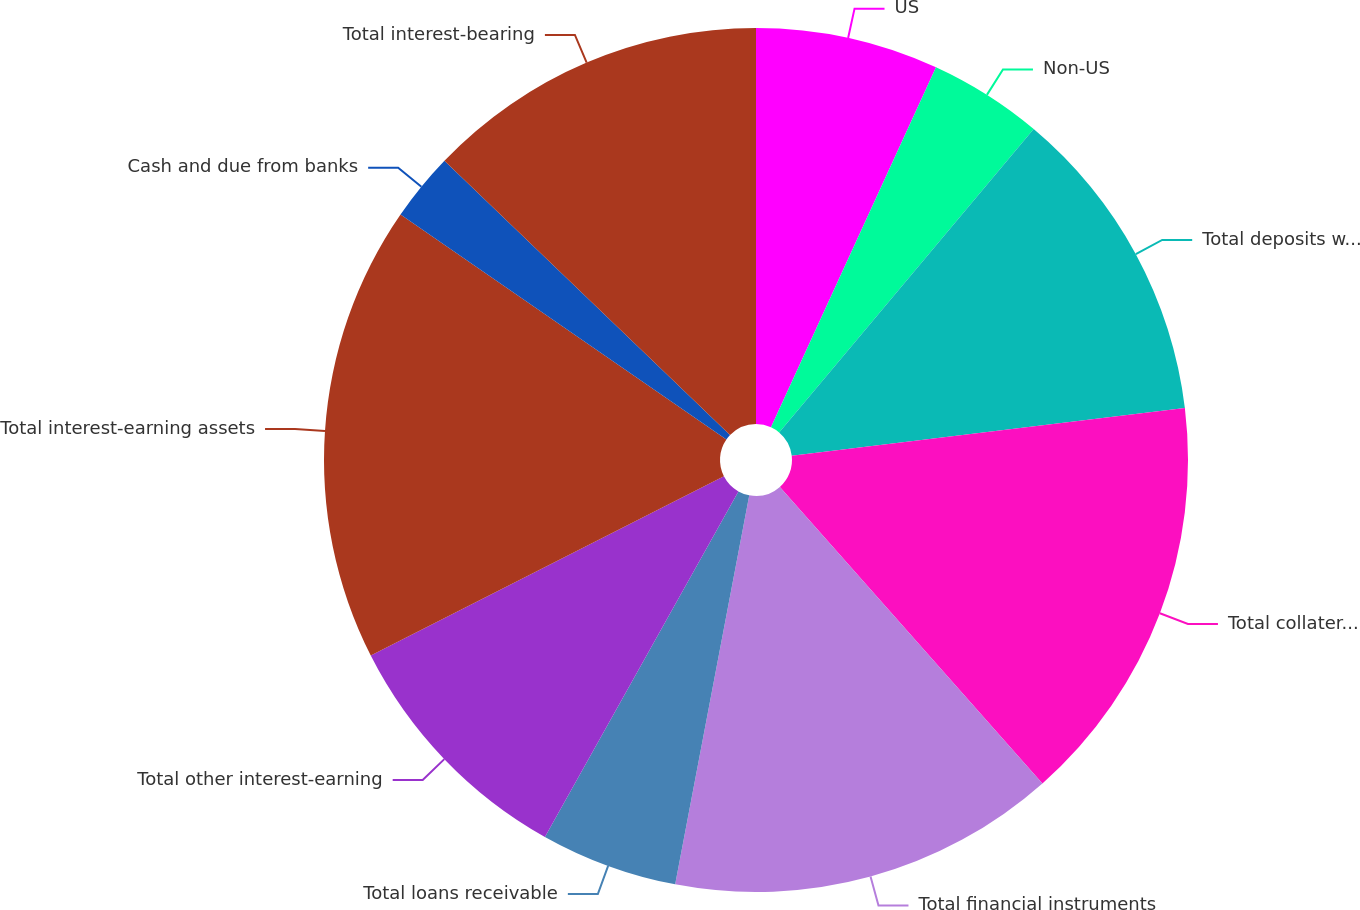Convert chart. <chart><loc_0><loc_0><loc_500><loc_500><pie_chart><fcel>US<fcel>Non-US<fcel>Total deposits with banks<fcel>Total collateralized<fcel>Total financial instruments<fcel>Total loans receivable<fcel>Total other interest-earning<fcel>Total interest-earning assets<fcel>Cash and due from banks<fcel>Total interest-bearing<nl><fcel>6.84%<fcel>4.27%<fcel>11.97%<fcel>15.38%<fcel>14.53%<fcel>5.13%<fcel>9.4%<fcel>17.09%<fcel>2.56%<fcel>12.82%<nl></chart> 